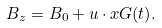<formula> <loc_0><loc_0><loc_500><loc_500>B _ { z } = B _ { 0 } + u \cdot x G ( t ) .</formula> 